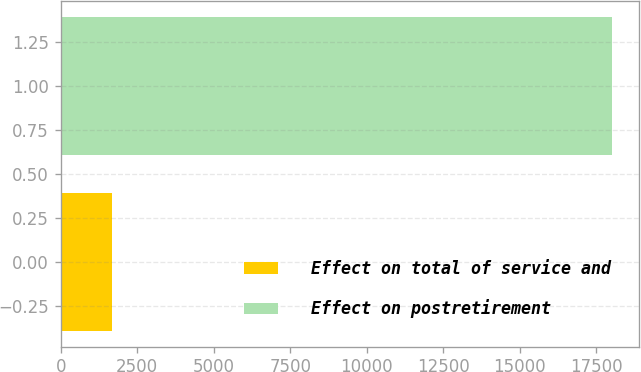Convert chart. <chart><loc_0><loc_0><loc_500><loc_500><bar_chart><fcel>Effect on total of service and<fcel>Effect on postretirement<nl><fcel>1665<fcel>18014<nl></chart> 